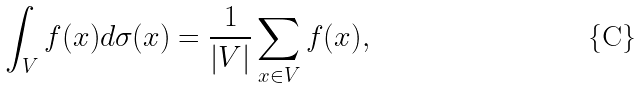<formula> <loc_0><loc_0><loc_500><loc_500>\int _ { V } f ( x ) d \sigma ( x ) = \frac { 1 } { | V | } \sum _ { x \in V } f ( x ) ,</formula> 